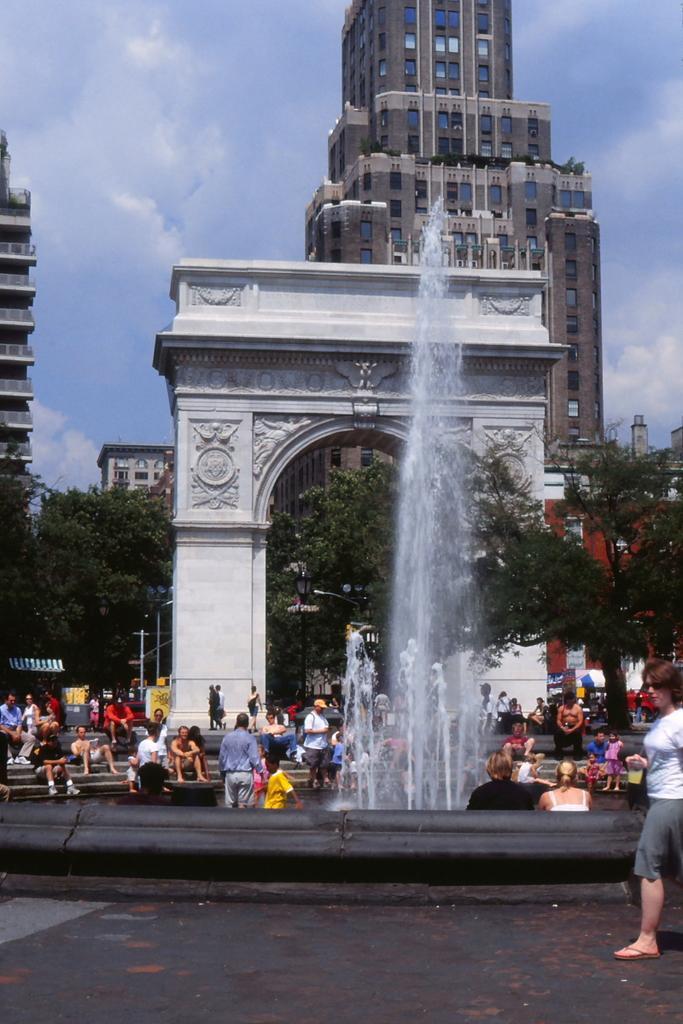Describe this image in one or two sentences. In the center of the image we can see an arch and also a water fountain. Image also consists of many people. In the background we can see some buildings and also trees. At the top there is sky with some clouds and at the bottom we can see the ground. 